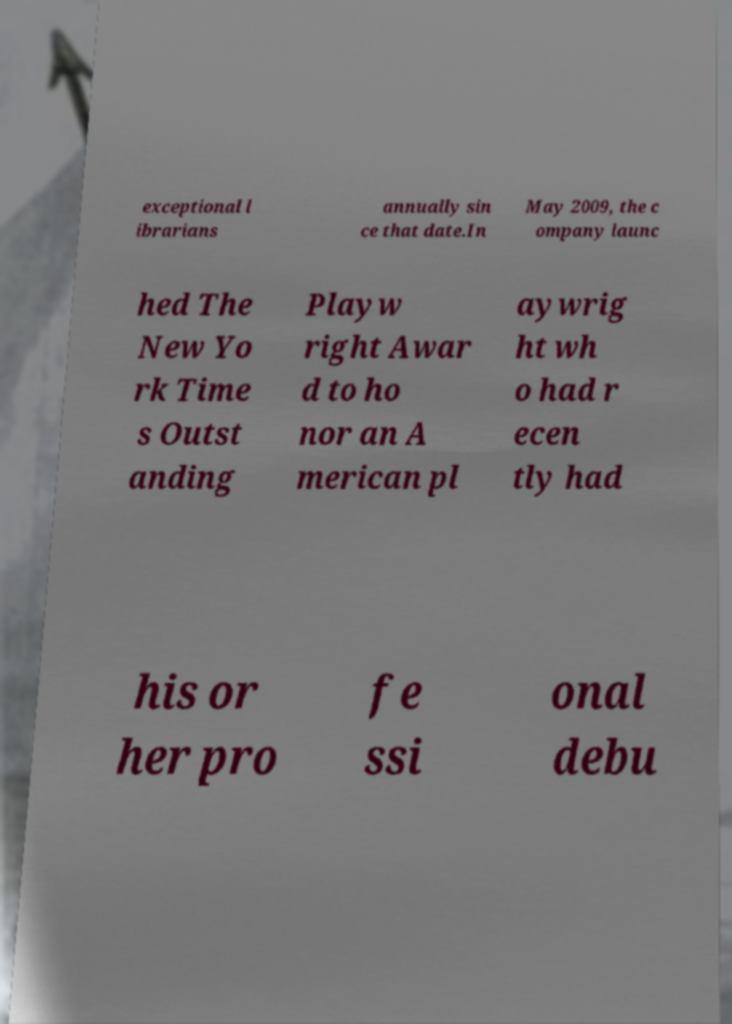I need the written content from this picture converted into text. Can you do that? exceptional l ibrarians annually sin ce that date.In May 2009, the c ompany launc hed The New Yo rk Time s Outst anding Playw right Awar d to ho nor an A merican pl aywrig ht wh o had r ecen tly had his or her pro fe ssi onal debu 